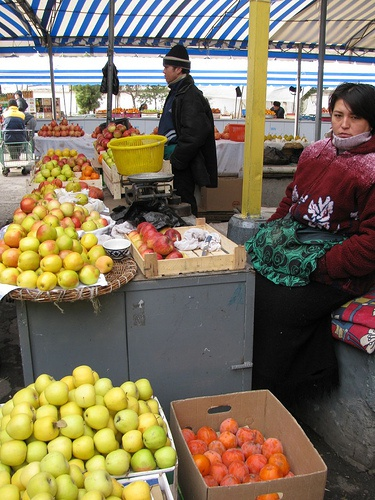Describe the objects in this image and their specific colors. I can see people in blue, black, maroon, teal, and gray tones, apple in blue, khaki, olive, and gold tones, apple in blue, khaki, orange, and olive tones, people in blue, black, gray, brown, and maroon tones, and apple in blue, tan, khaki, and olive tones in this image. 